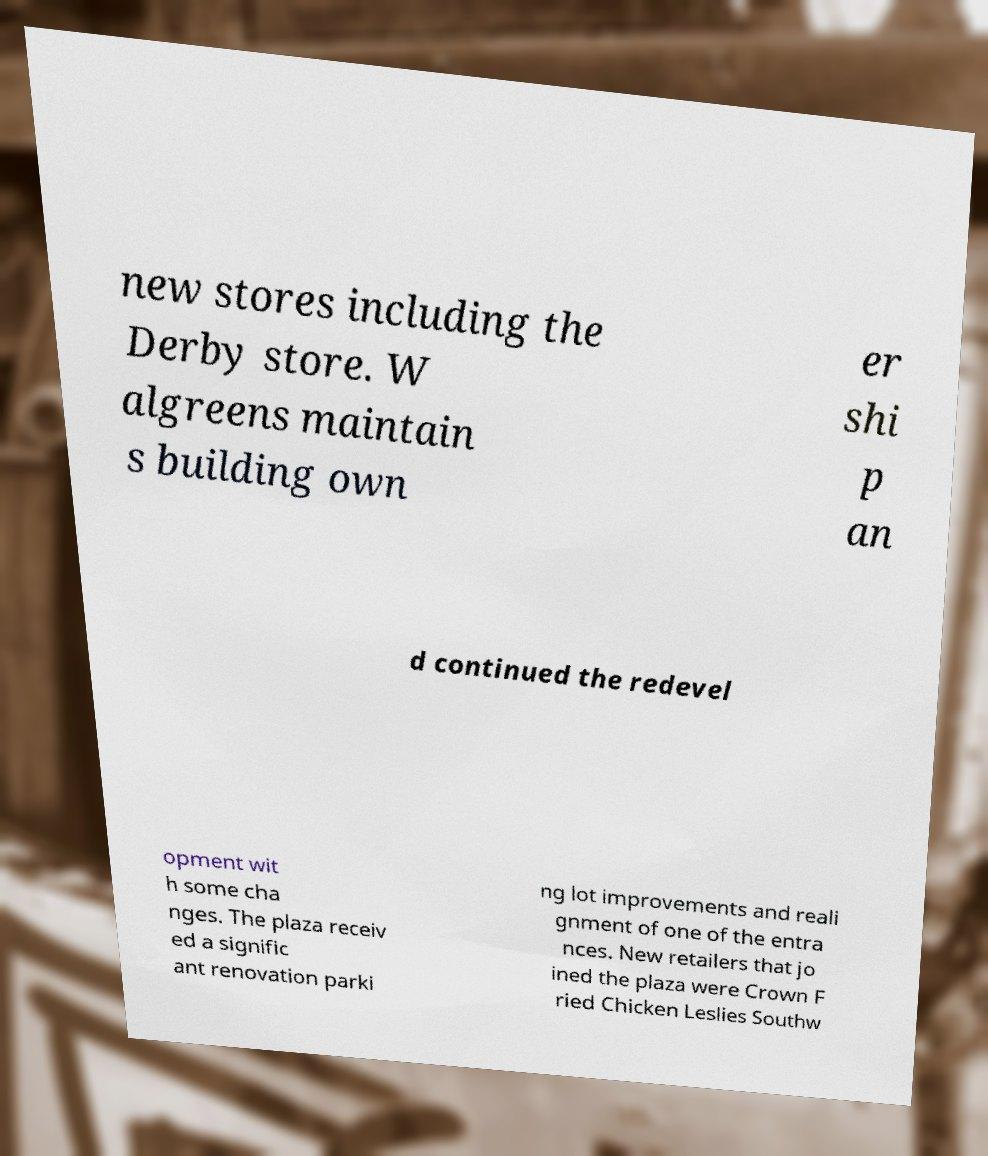Can you read and provide the text displayed in the image?This photo seems to have some interesting text. Can you extract and type it out for me? new stores including the Derby store. W algreens maintain s building own er shi p an d continued the redevel opment wit h some cha nges. The plaza receiv ed a signific ant renovation parki ng lot improvements and reali gnment of one of the entra nces. New retailers that jo ined the plaza were Crown F ried Chicken Leslies Southw 